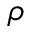<formula> <loc_0><loc_0><loc_500><loc_500>\rho</formula> 